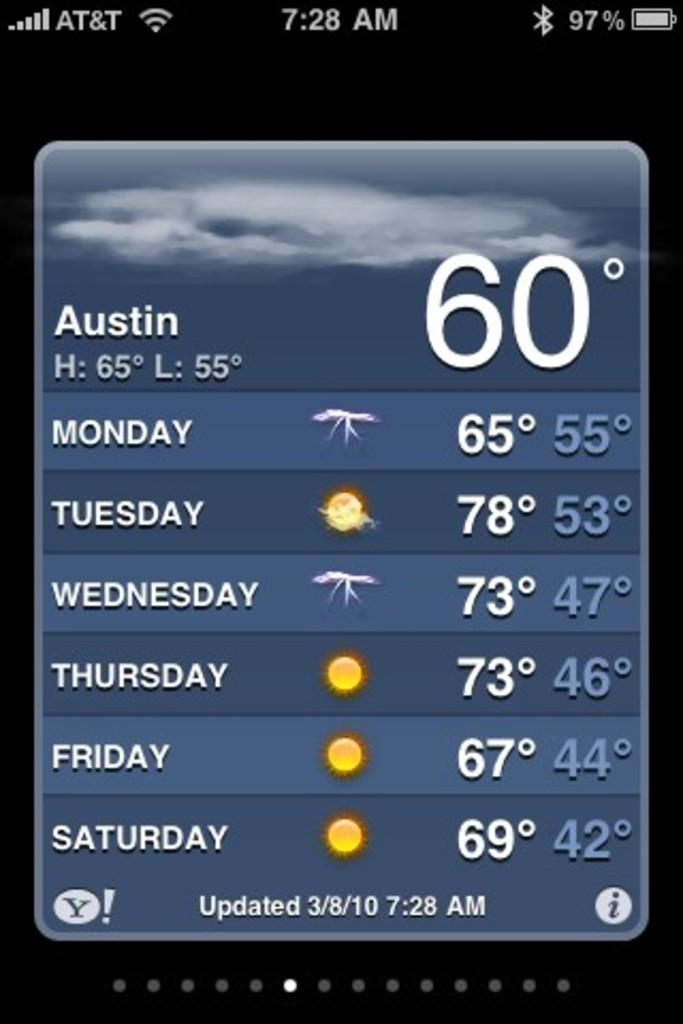Provide a one-sentence caption for the provided image. The temperature in Austin is currently 60 degrees, and the forecast for Monday through Saturday is shown. 